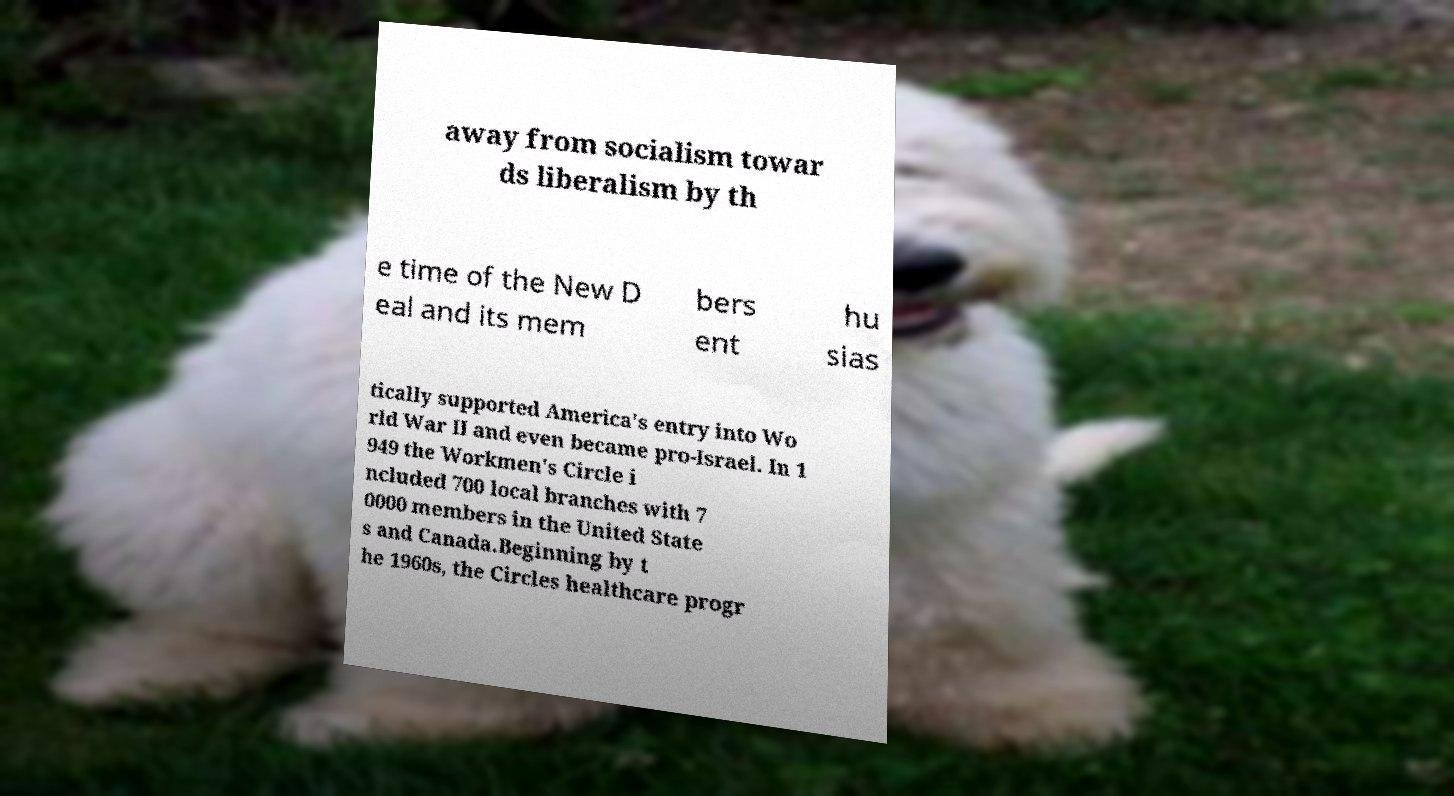Please identify and transcribe the text found in this image. away from socialism towar ds liberalism by th e time of the New D eal and its mem bers ent hu sias tically supported America's entry into Wo rld War II and even became pro-Israel. In 1 949 the Workmen's Circle i ncluded 700 local branches with 7 0000 members in the United State s and Canada.Beginning by t he 1960s, the Circles healthcare progr 